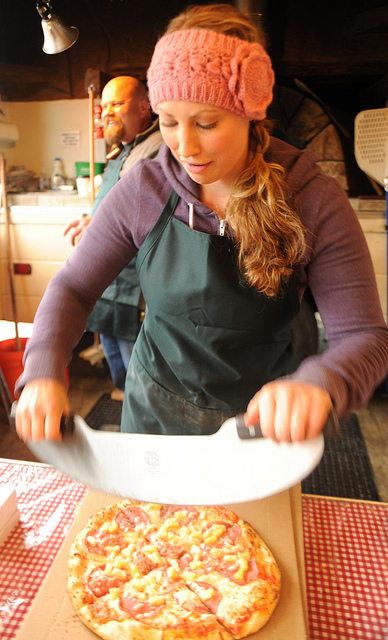<image>Where is the blue scarf? The blue scarf is not pictured in the image. However, it could be in a drawer or on a man's neck. Where is the blue scarf? It is unknown where the blue scarf is located. It is not pictured. 